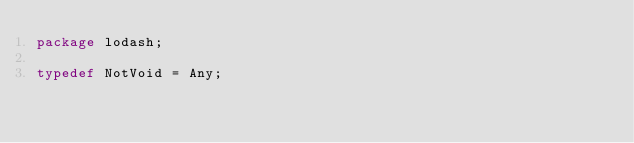<code> <loc_0><loc_0><loc_500><loc_500><_Haxe_>package lodash;

typedef NotVoid = Any;</code> 